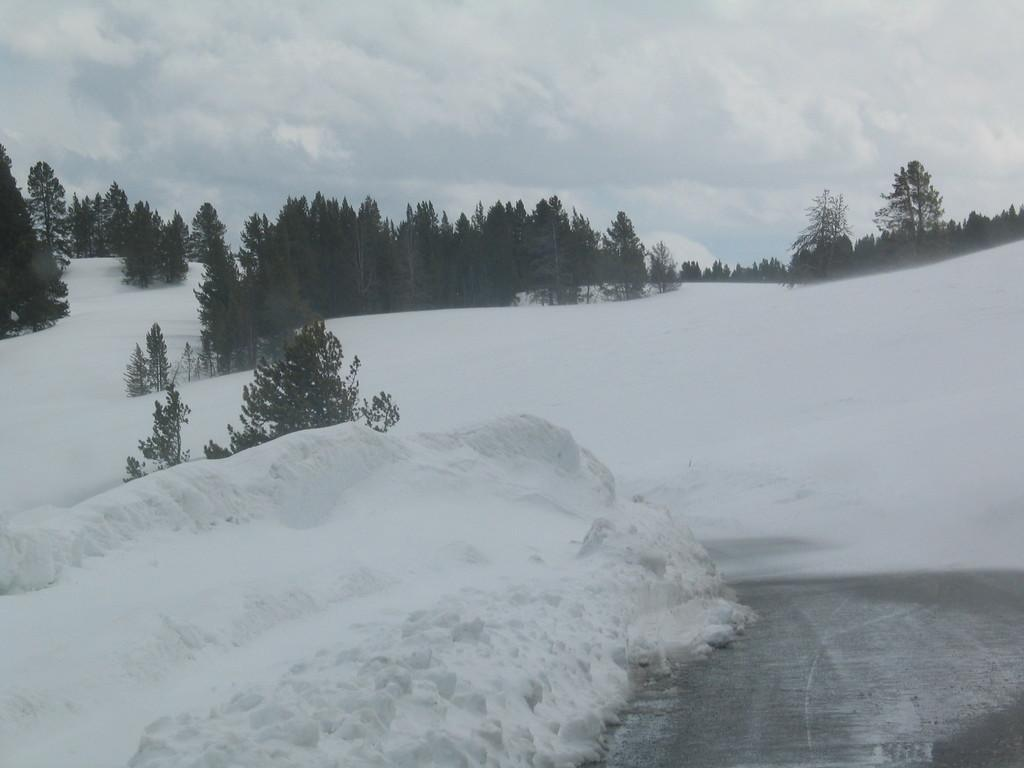What type of surface can be seen in the image? There is a road in the image. What is covering the ground in the image? There is snow visible in the image. What type of vegetation is present in the image? There are trees in the image. What is visible above the trees and road in the image? The sky is visible in the image. What type of question is being asked in the image? There is no question being asked in the image; it is a visual representation of a scene with a road, snow, trees, and sky. Can you tell me the weight of the quartz in the image? There is no quartz present in the image, so its weight cannot be determined. 